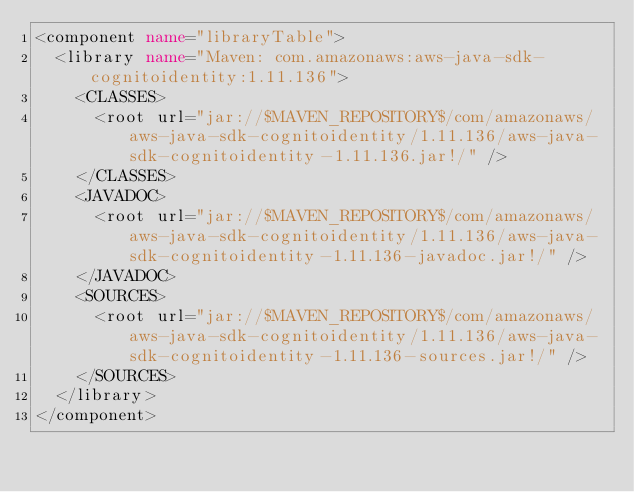Convert code to text. <code><loc_0><loc_0><loc_500><loc_500><_XML_><component name="libraryTable">
  <library name="Maven: com.amazonaws:aws-java-sdk-cognitoidentity:1.11.136">
    <CLASSES>
      <root url="jar://$MAVEN_REPOSITORY$/com/amazonaws/aws-java-sdk-cognitoidentity/1.11.136/aws-java-sdk-cognitoidentity-1.11.136.jar!/" />
    </CLASSES>
    <JAVADOC>
      <root url="jar://$MAVEN_REPOSITORY$/com/amazonaws/aws-java-sdk-cognitoidentity/1.11.136/aws-java-sdk-cognitoidentity-1.11.136-javadoc.jar!/" />
    </JAVADOC>
    <SOURCES>
      <root url="jar://$MAVEN_REPOSITORY$/com/amazonaws/aws-java-sdk-cognitoidentity/1.11.136/aws-java-sdk-cognitoidentity-1.11.136-sources.jar!/" />
    </SOURCES>
  </library>
</component></code> 